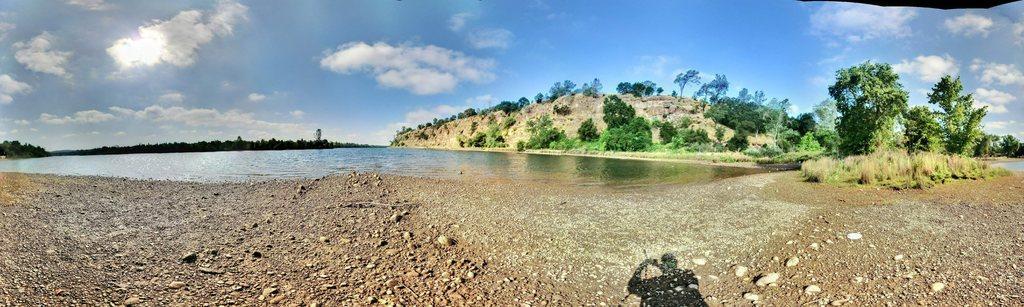Can you describe this image briefly? In this image we can see trees, sky, water, mountain. At the bottom of the image there is shadow of a person and stones. 